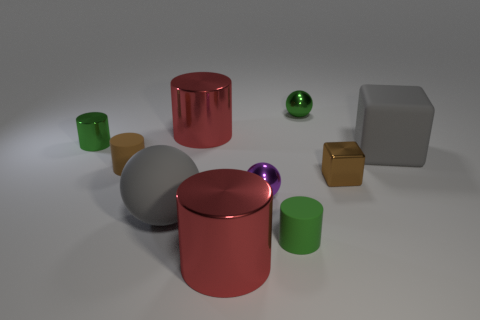Subtract all metal balls. How many balls are left? 1 Subtract all brown cylinders. How many cylinders are left? 4 Subtract 1 cubes. How many cubes are left? 1 Subtract all balls. How many objects are left? 7 Subtract 0 red cubes. How many objects are left? 10 Subtract all green cubes. Subtract all red cylinders. How many cubes are left? 2 Subtract all green cubes. How many brown balls are left? 0 Subtract all green metallic cylinders. Subtract all brown objects. How many objects are left? 7 Add 9 small purple metal objects. How many small purple metal objects are left? 10 Add 2 big things. How many big things exist? 6 